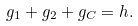Convert formula to latex. <formula><loc_0><loc_0><loc_500><loc_500>g _ { 1 } + g _ { 2 } + g _ { C } = h .</formula> 